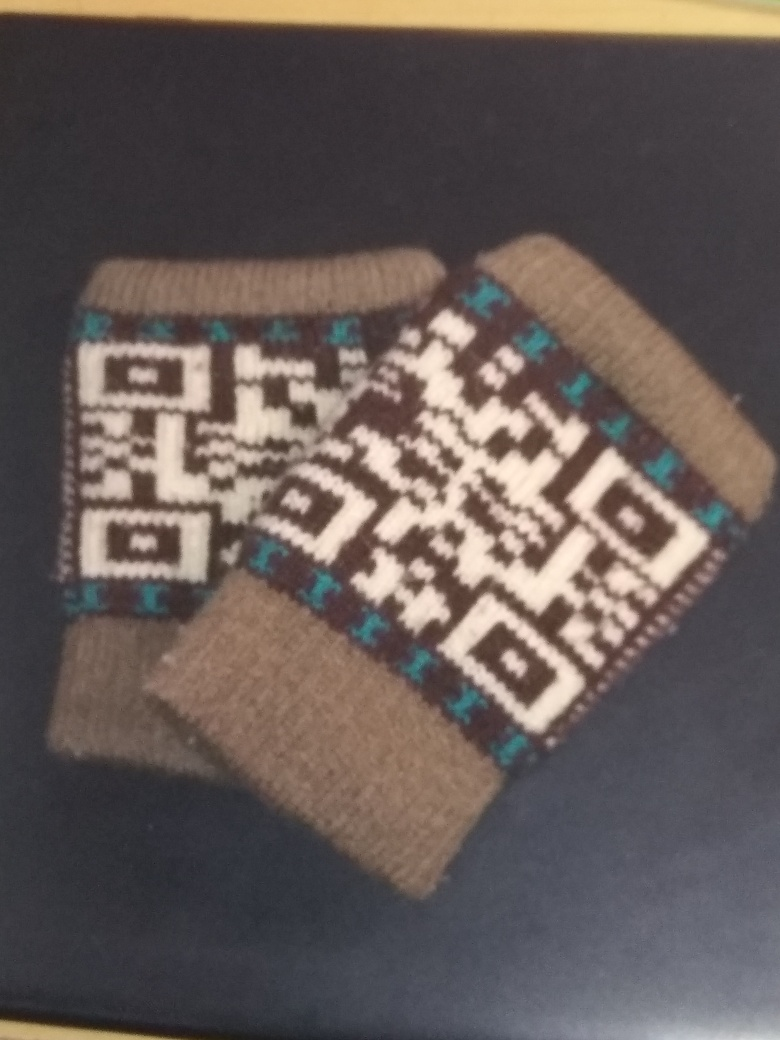How would you describe the texture and material of the socks displayed in the image? The socks appear to be made from wool, which suggests they have a soft and warm texture suitable for colder climates, providing comfort and insulation. 